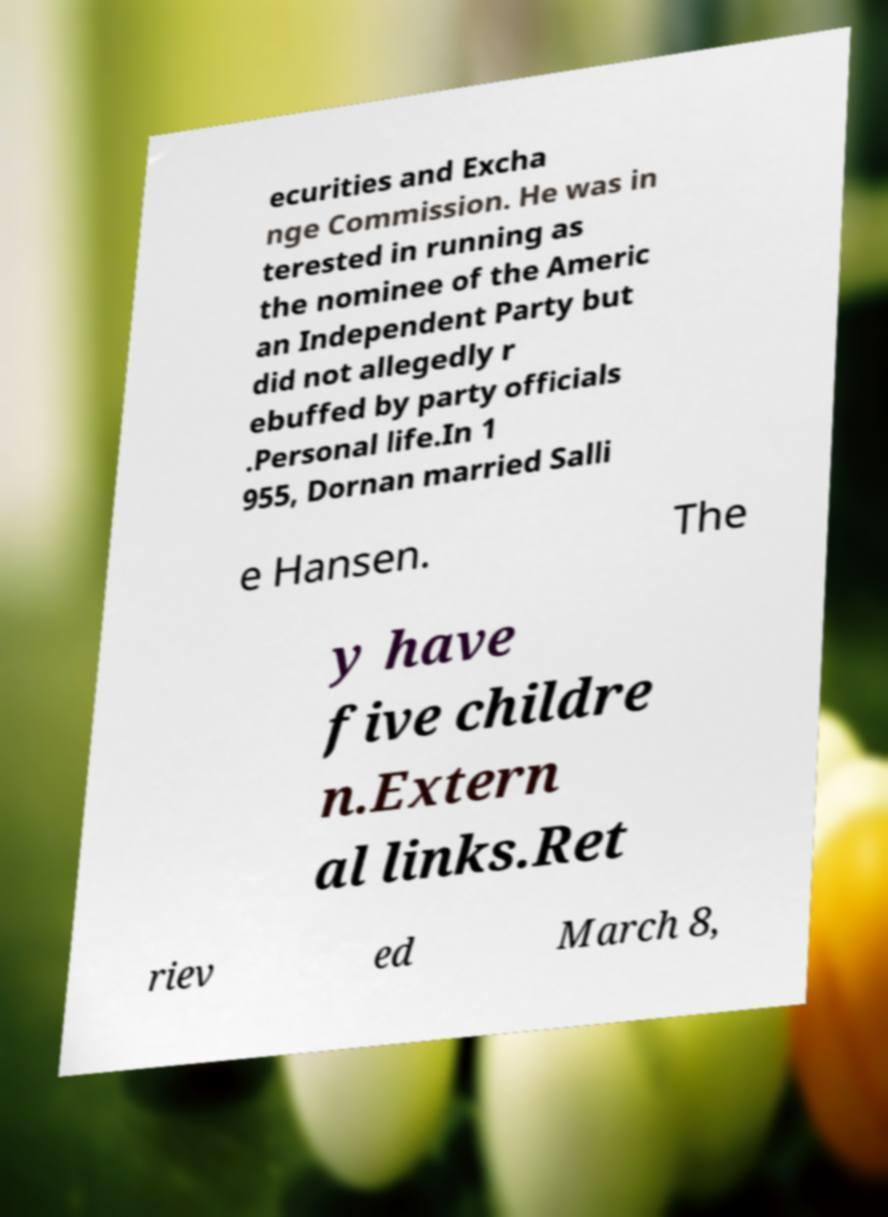For documentation purposes, I need the text within this image transcribed. Could you provide that? ecurities and Excha nge Commission. He was in terested in running as the nominee of the Americ an Independent Party but did not allegedly r ebuffed by party officials .Personal life.In 1 955, Dornan married Salli e Hansen. The y have five childre n.Extern al links.Ret riev ed March 8, 